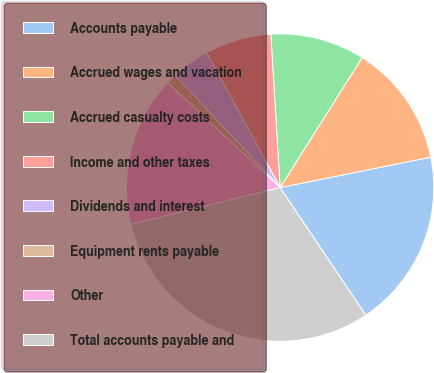<chart> <loc_0><loc_0><loc_500><loc_500><pie_chart><fcel>Accounts payable<fcel>Accrued wages and vacation<fcel>Accrued casualty costs<fcel>Income and other taxes<fcel>Dividends and interest<fcel>Equipment rents payable<fcel>Other<fcel>Total accounts payable and<nl><fcel>18.76%<fcel>12.87%<fcel>9.92%<fcel>6.98%<fcel>4.03%<fcel>1.08%<fcel>15.81%<fcel>30.54%<nl></chart> 